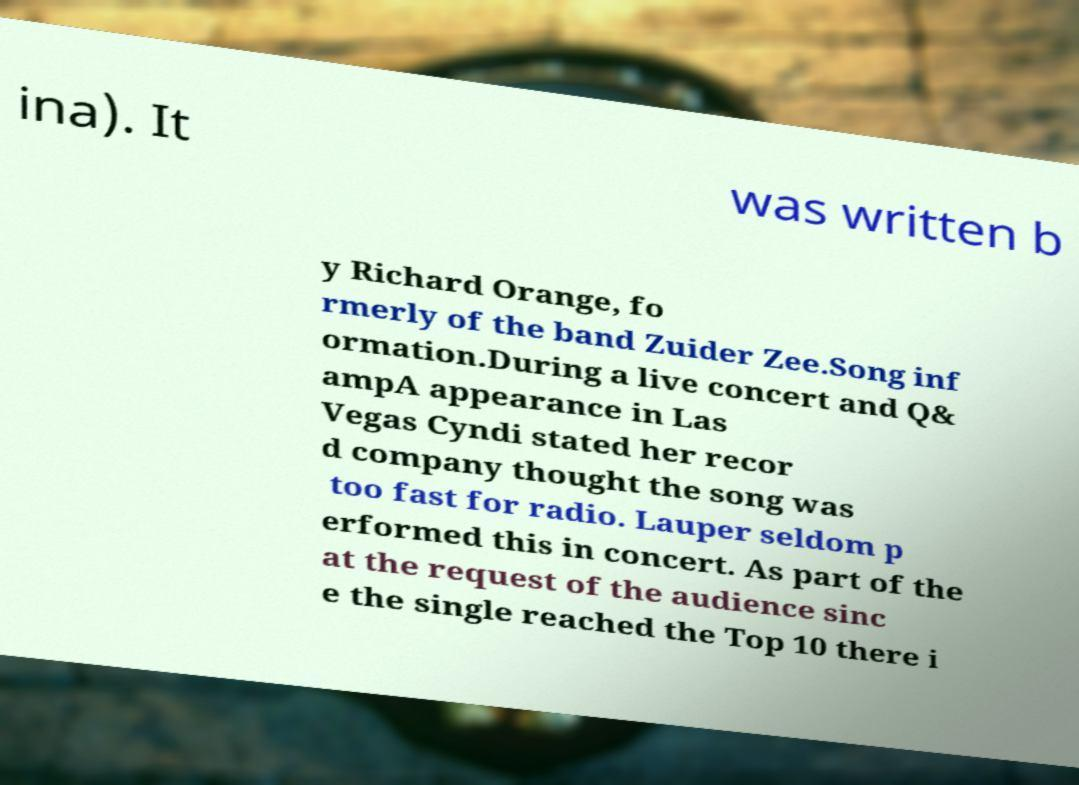I need the written content from this picture converted into text. Can you do that? ina). It was written b y Richard Orange, fo rmerly of the band Zuider Zee.Song inf ormation.During a live concert and Q& ampA appearance in Las Vegas Cyndi stated her recor d company thought the song was too fast for radio. Lauper seldom p erformed this in concert. As part of the at the request of the audience sinc e the single reached the Top 10 there i 